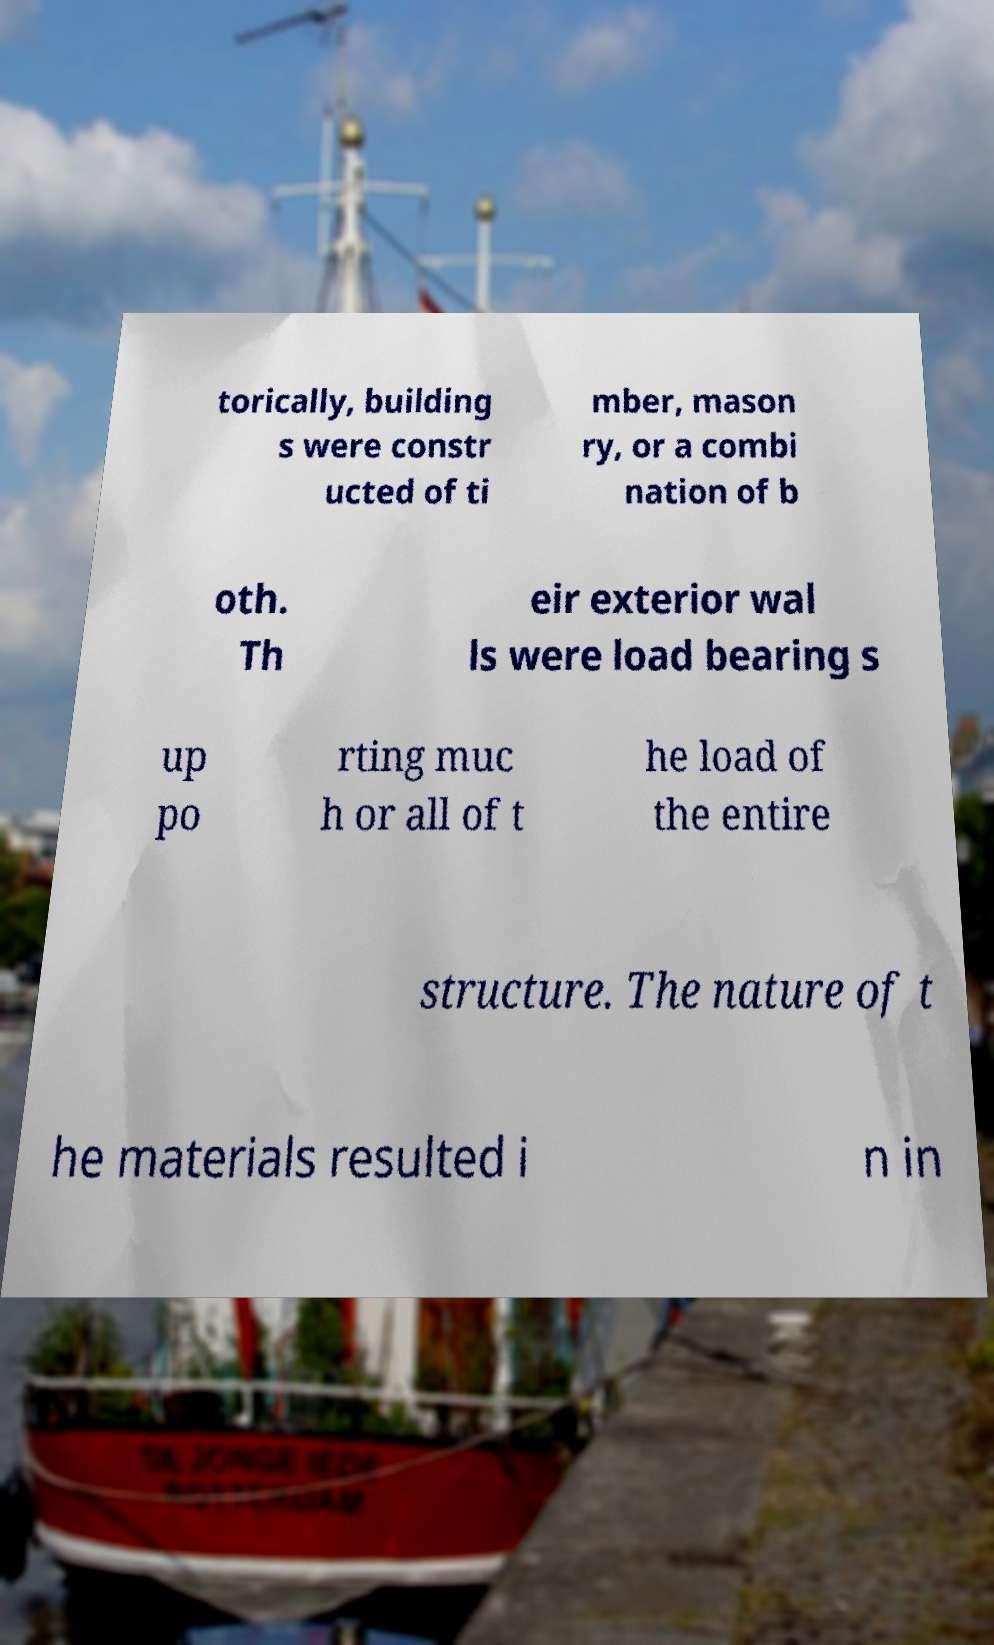Can you accurately transcribe the text from the provided image for me? torically, building s were constr ucted of ti mber, mason ry, or a combi nation of b oth. Th eir exterior wal ls were load bearing s up po rting muc h or all of t he load of the entire structure. The nature of t he materials resulted i n in 